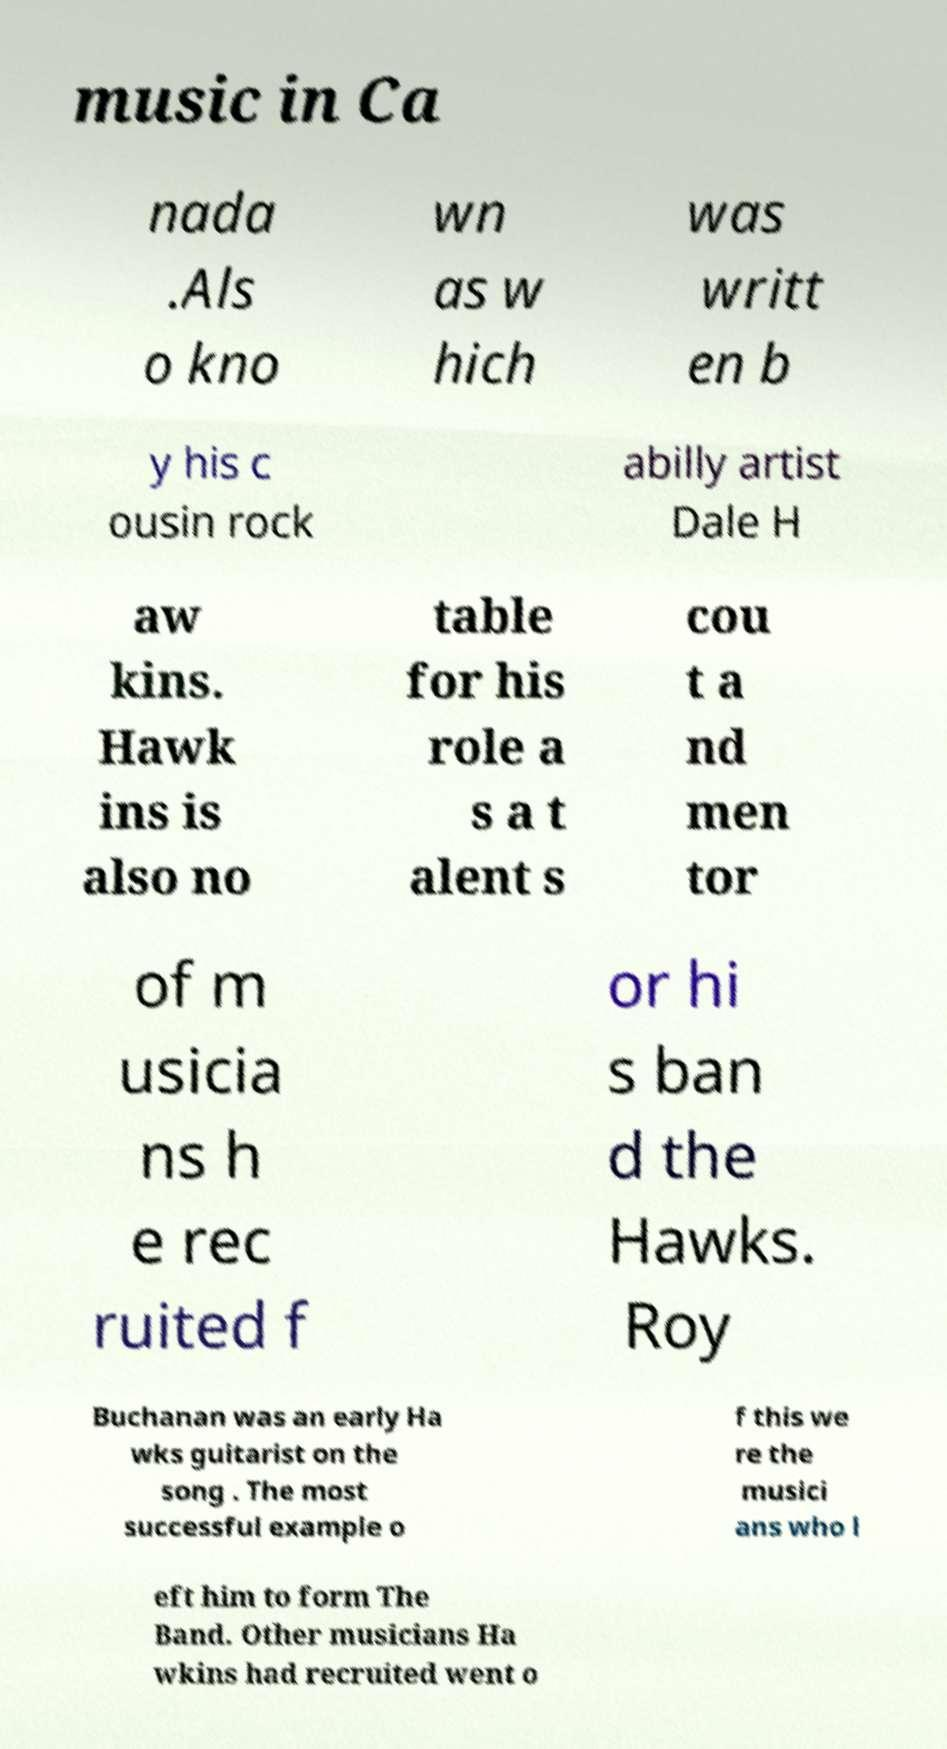Please identify and transcribe the text found in this image. music in Ca nada .Als o kno wn as w hich was writt en b y his c ousin rock abilly artist Dale H aw kins. Hawk ins is also no table for his role a s a t alent s cou t a nd men tor of m usicia ns h e rec ruited f or hi s ban d the Hawks. Roy Buchanan was an early Ha wks guitarist on the song . The most successful example o f this we re the musici ans who l eft him to form The Band. Other musicians Ha wkins had recruited went o 